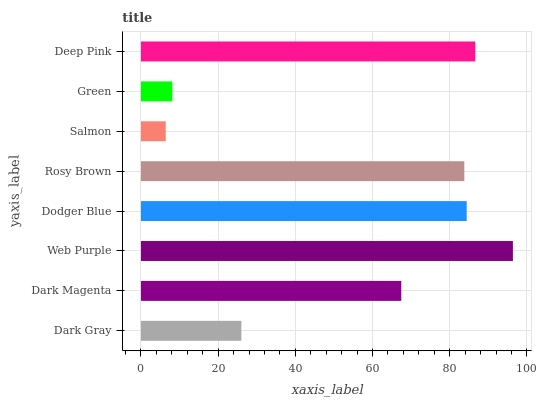Is Salmon the minimum?
Answer yes or no. Yes. Is Web Purple the maximum?
Answer yes or no. Yes. Is Dark Magenta the minimum?
Answer yes or no. No. Is Dark Magenta the maximum?
Answer yes or no. No. Is Dark Magenta greater than Dark Gray?
Answer yes or no. Yes. Is Dark Gray less than Dark Magenta?
Answer yes or no. Yes. Is Dark Gray greater than Dark Magenta?
Answer yes or no. No. Is Dark Magenta less than Dark Gray?
Answer yes or no. No. Is Rosy Brown the high median?
Answer yes or no. Yes. Is Dark Magenta the low median?
Answer yes or no. Yes. Is Web Purple the high median?
Answer yes or no. No. Is Green the low median?
Answer yes or no. No. 